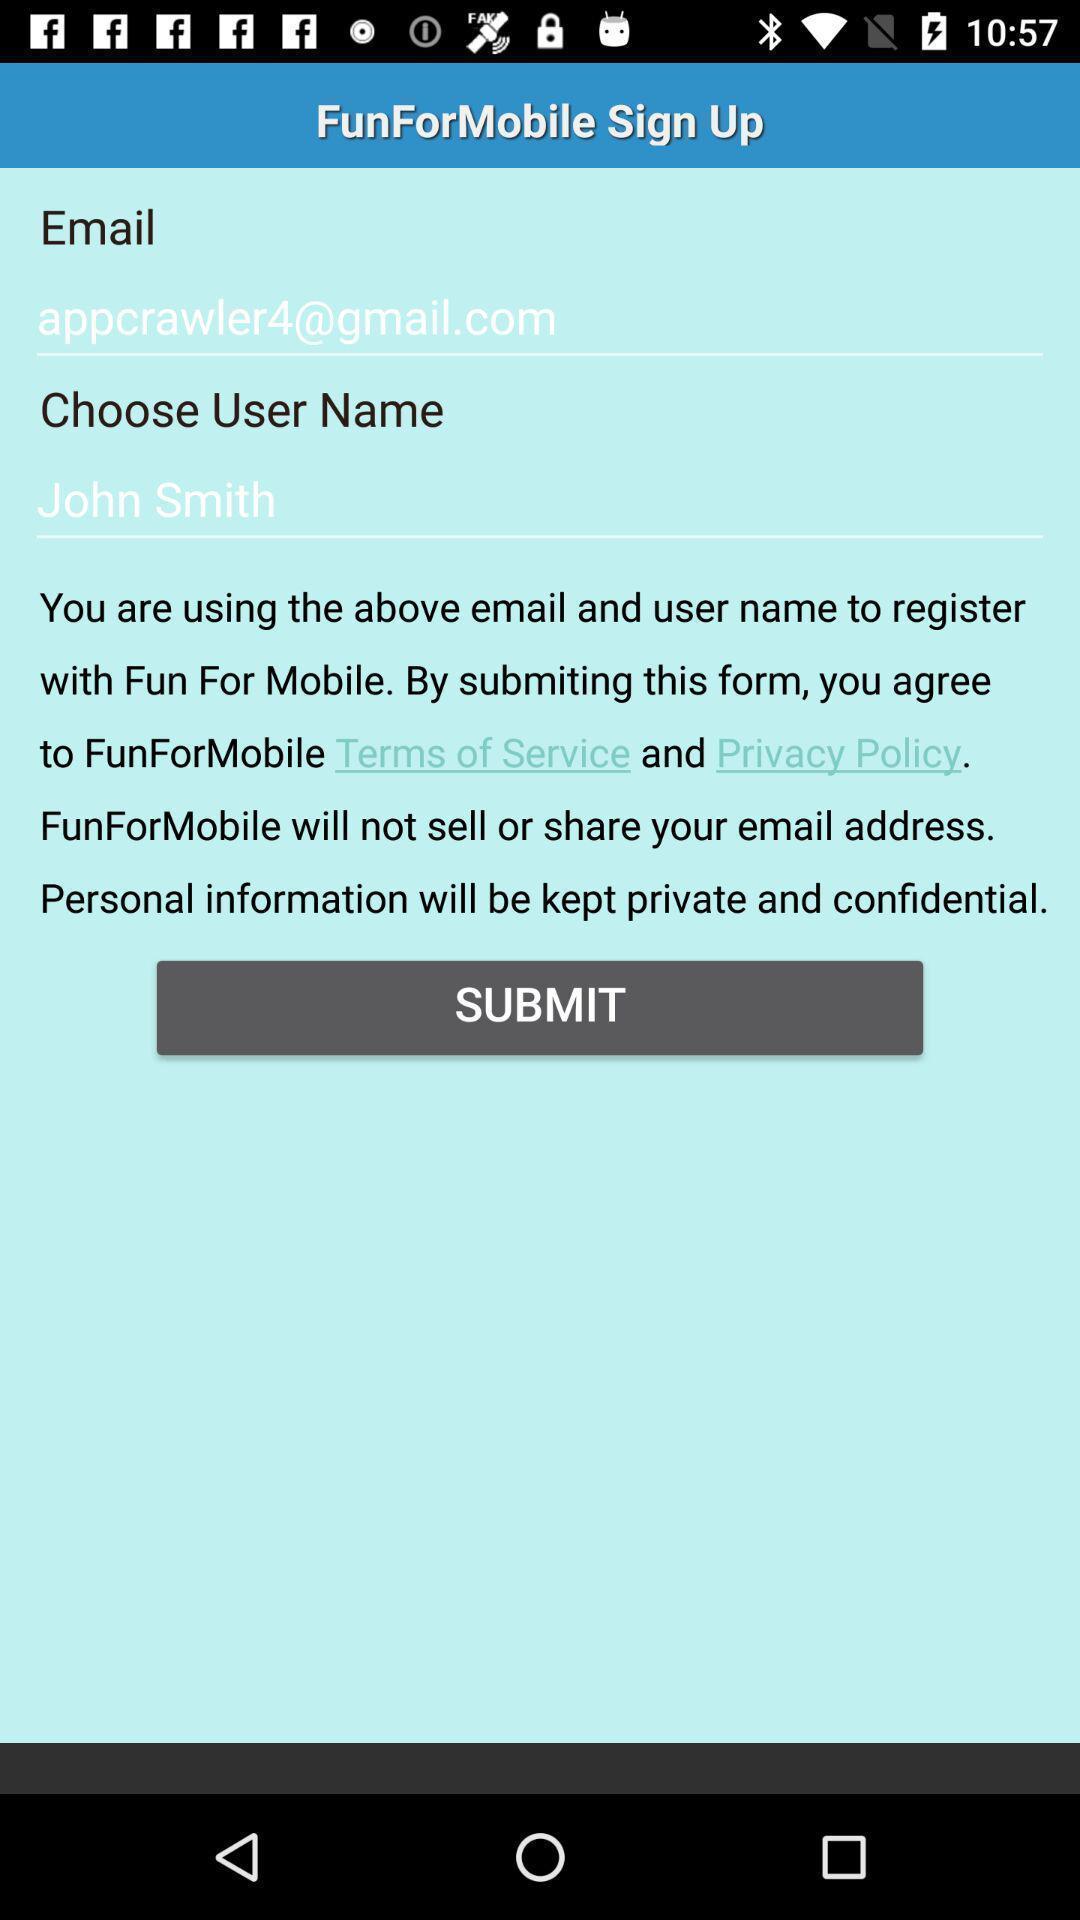Provide a detailed account of this screenshot. Submit page for sign up. 